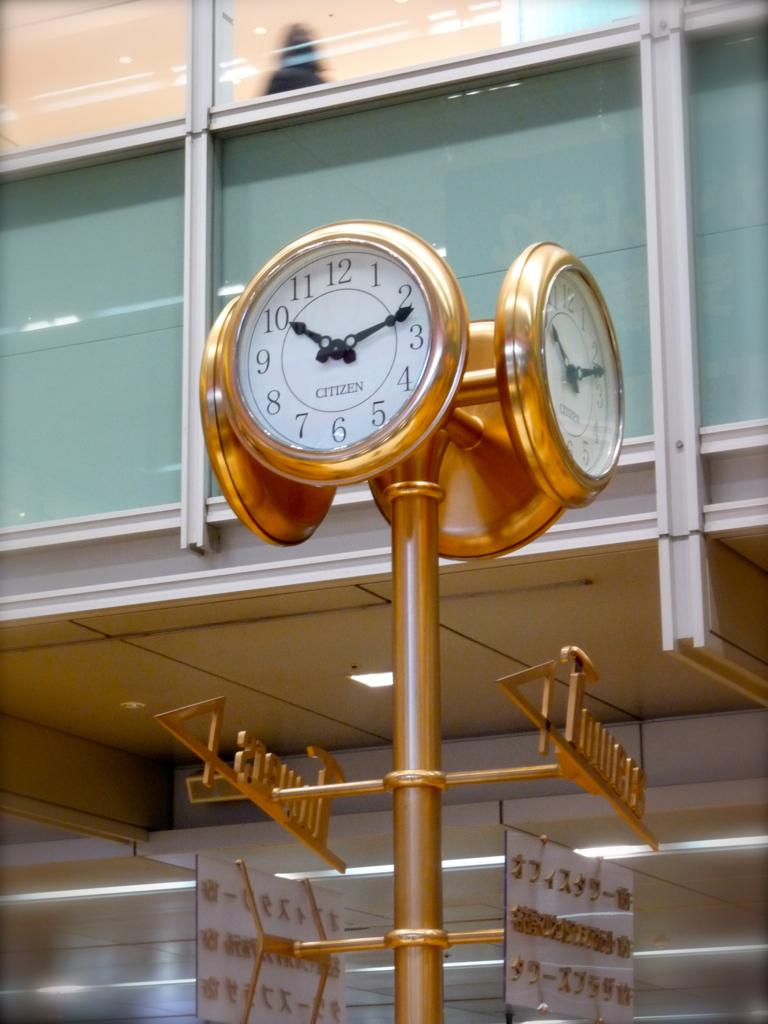<image>
Present a compact description of the photo's key features. A gold Citizen clock is up on a gold stand. 